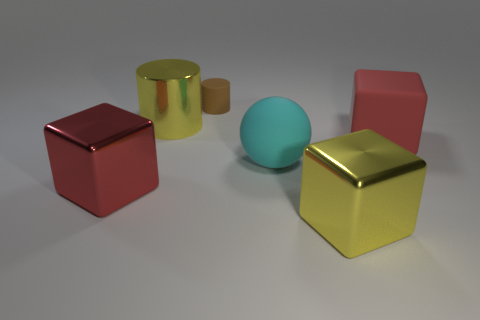Add 4 small yellow metal objects. How many objects exist? 10 Subtract all balls. How many objects are left? 5 Subtract 0 purple cubes. How many objects are left? 6 Subtract all large red cylinders. Subtract all tiny brown rubber objects. How many objects are left? 5 Add 4 yellow metallic blocks. How many yellow metallic blocks are left? 5 Add 4 tiny gray spheres. How many tiny gray spheres exist? 4 